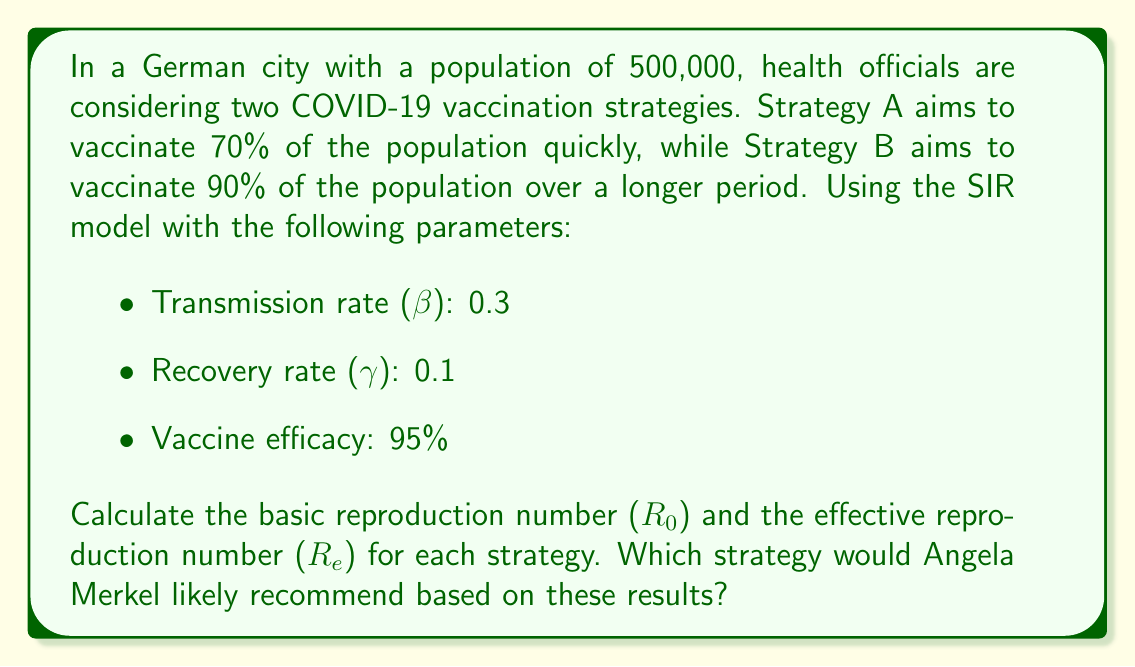Show me your answer to this math problem. To solve this problem, we'll follow these steps:

1. Calculate the basic reproduction number (R0)
2. Calculate the effective reproduction number (Re) for each strategy
3. Compare the results and determine the recommended strategy

Step 1: Calculate R0

The basic reproduction number (R0) is given by the formula:

$$ R_0 = \frac{\beta}{\gamma} $$

Where β is the transmission rate and γ is the recovery rate.

$$ R_0 = \frac{0.3}{0.1} = 3 $$

Step 2: Calculate Re for each strategy

The effective reproduction number (Re) is calculated using the formula:

$$ R_e = R_0 \cdot (1 - p \cdot e) $$

Where p is the proportion of the population vaccinated, and e is the vaccine efficacy.

For Strategy A (70% vaccination):
$$ R_e^A = 3 \cdot (1 - 0.70 \cdot 0.95) = 3 \cdot (1 - 0.665) = 3 \cdot 0.335 = 1.005 $$

For Strategy B (90% vaccination):
$$ R_e^B = 3 \cdot (1 - 0.90 \cdot 0.95) = 3 \cdot (1 - 0.855) = 3 \cdot 0.145 = 0.435 $$

Step 3: Compare results and determine the recommended strategy

Strategy A results in an Re value of 1.005, which is slightly above 1. This means the epidemic would continue to spread, albeit very slowly.

Strategy B results in an Re value of 0.435, which is well below 1. This means the epidemic would be effectively controlled and eventually die out.

Given Angela Merkel's background as a scientist and her cautious approach to the COVID-19 pandemic, she would likely recommend Strategy B. Although it takes longer to implement, it provides better control of the epidemic and reduces the risk of future outbreaks.
Answer: Angela Merkel would likely recommend Strategy B (90% vaccination) because it results in a lower effective reproduction number (Re = 0.435) compared to Strategy A (Re = 1.005). Strategy B is more effective in controlling the spread of COVID-19 and reducing the risk of future outbreaks. 